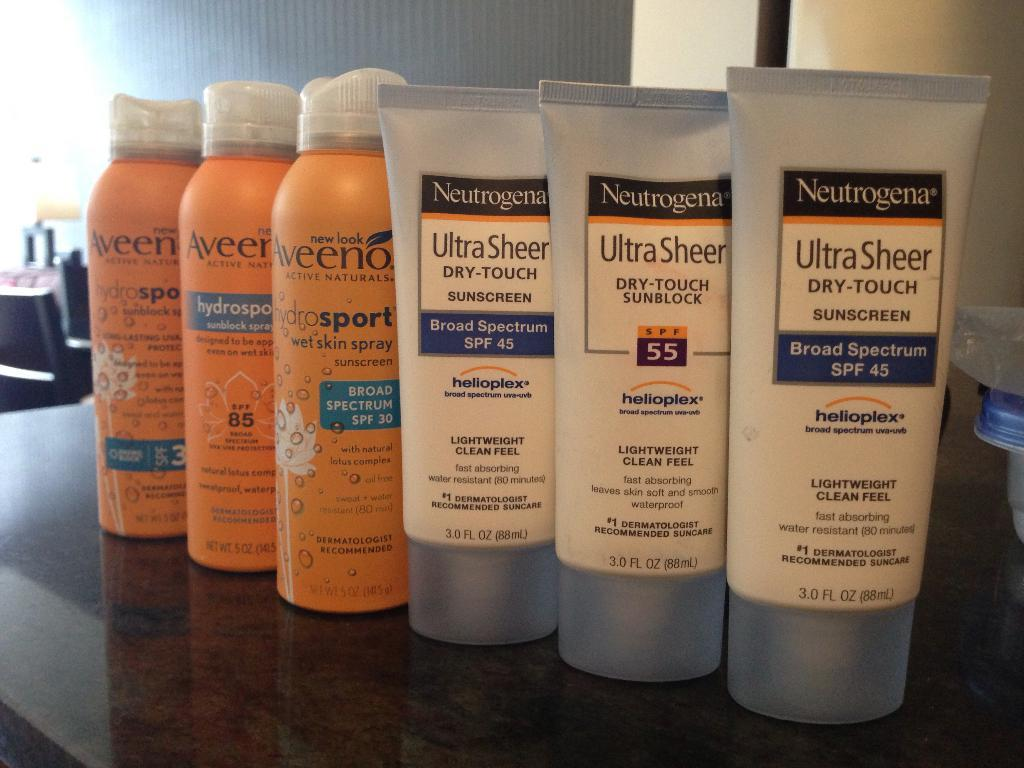<image>
Create a compact narrative representing the image presented. three bottles of aveeno products and 3 tubes of neutrogena ultra sheen dry-touch sunscreen 